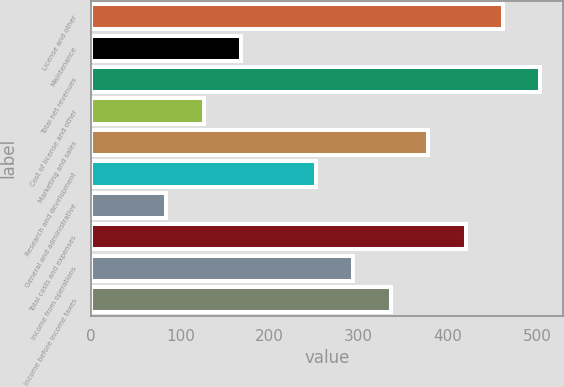<chart> <loc_0><loc_0><loc_500><loc_500><bar_chart><fcel>License and other<fcel>Maintenance<fcel>Total net revenues<fcel>Cost of license and other<fcel>Marketing and sales<fcel>Research and development<fcel>General and administrative<fcel>Total costs and expenses<fcel>Income from operations<fcel>Income before income taxes<nl><fcel>461.79<fcel>168.14<fcel>503.74<fcel>126.19<fcel>377.89<fcel>252.04<fcel>84.24<fcel>419.84<fcel>293.99<fcel>335.94<nl></chart> 